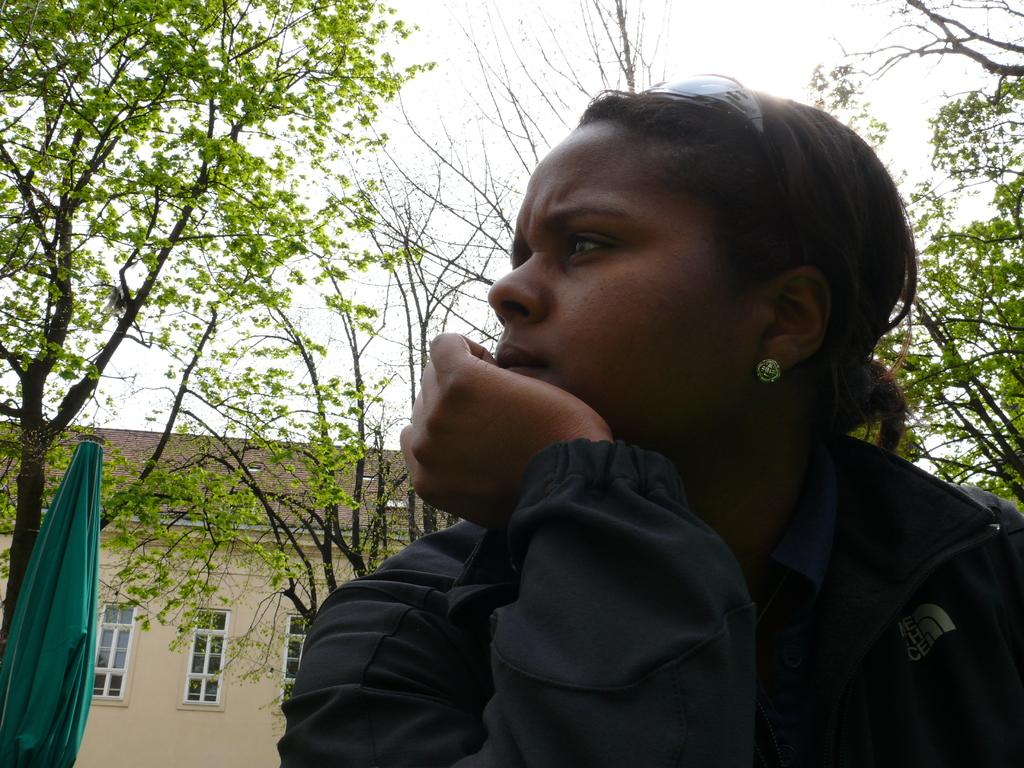What is the main subject of the image? There is a woman in the image. What can be seen in the background of the image? There is a cloth, a house, trees, and the sky visible in the background of the image. What type of glass is the woman holding in the image? There is no glass present in the image. Where is the office located in the image? There is no office present in the image. What is the woman using to cover her face in the image? The woman is not using anything to cover her face in the image. 